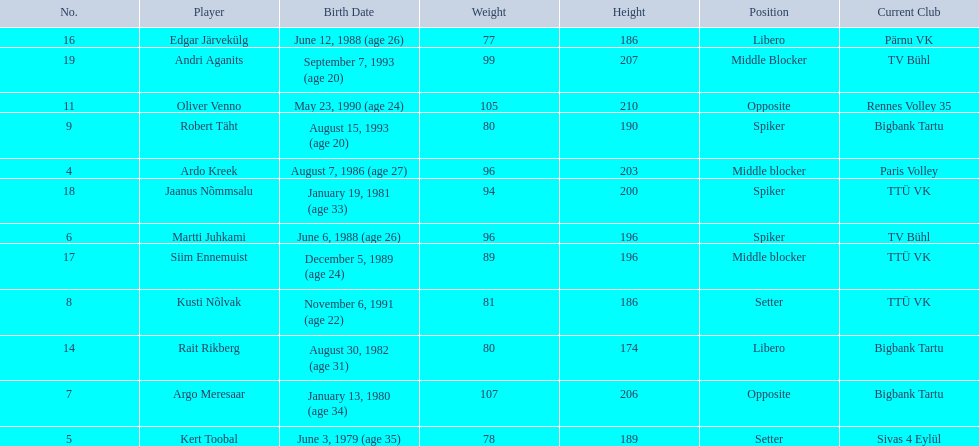What are the heights in cm of the men on the team? 203, 189, 196, 206, 186, 190, 210, 174, 186, 196, 200, 207. What is the tallest height of a team member? 210. Which player stands at 210? Oliver Venno. 